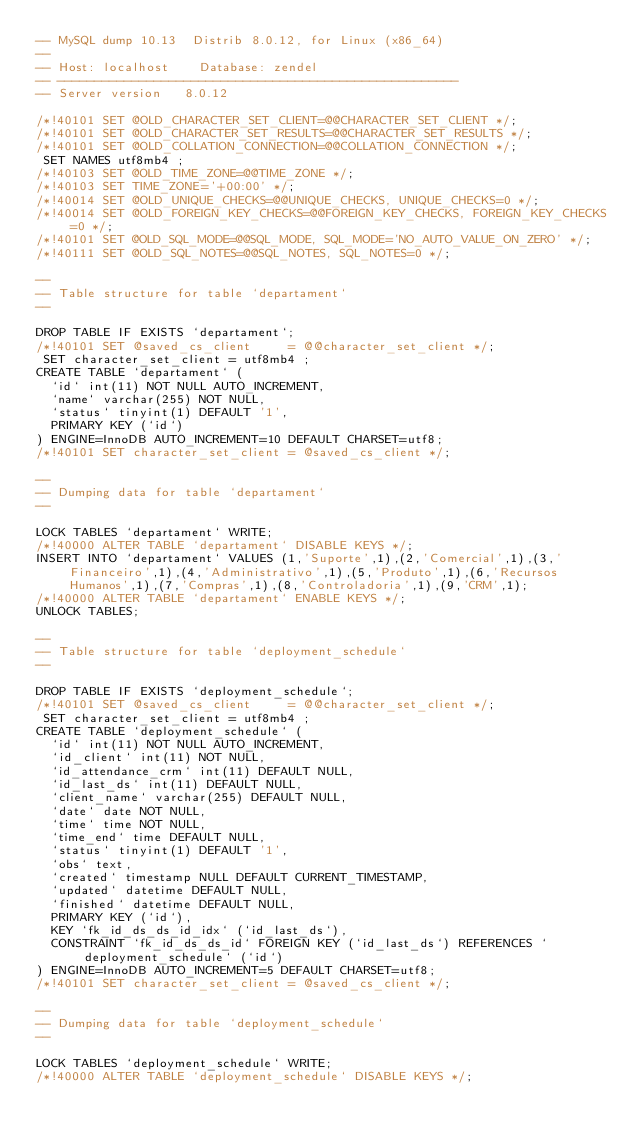<code> <loc_0><loc_0><loc_500><loc_500><_SQL_>-- MySQL dump 10.13  Distrib 8.0.12, for Linux (x86_64)
--
-- Host: localhost    Database: zendel
-- ------------------------------------------------------
-- Server version	8.0.12

/*!40101 SET @OLD_CHARACTER_SET_CLIENT=@@CHARACTER_SET_CLIENT */;
/*!40101 SET @OLD_CHARACTER_SET_RESULTS=@@CHARACTER_SET_RESULTS */;
/*!40101 SET @OLD_COLLATION_CONNECTION=@@COLLATION_CONNECTION */;
 SET NAMES utf8mb4 ;
/*!40103 SET @OLD_TIME_ZONE=@@TIME_ZONE */;
/*!40103 SET TIME_ZONE='+00:00' */;
/*!40014 SET @OLD_UNIQUE_CHECKS=@@UNIQUE_CHECKS, UNIQUE_CHECKS=0 */;
/*!40014 SET @OLD_FOREIGN_KEY_CHECKS=@@FOREIGN_KEY_CHECKS, FOREIGN_KEY_CHECKS=0 */;
/*!40101 SET @OLD_SQL_MODE=@@SQL_MODE, SQL_MODE='NO_AUTO_VALUE_ON_ZERO' */;
/*!40111 SET @OLD_SQL_NOTES=@@SQL_NOTES, SQL_NOTES=0 */;

--
-- Table structure for table `departament`
--

DROP TABLE IF EXISTS `departament`;
/*!40101 SET @saved_cs_client     = @@character_set_client */;
 SET character_set_client = utf8mb4 ;
CREATE TABLE `departament` (
  `id` int(11) NOT NULL AUTO_INCREMENT,
  `name` varchar(255) NOT NULL,
  `status` tinyint(1) DEFAULT '1',
  PRIMARY KEY (`id`)
) ENGINE=InnoDB AUTO_INCREMENT=10 DEFAULT CHARSET=utf8;
/*!40101 SET character_set_client = @saved_cs_client */;

--
-- Dumping data for table `departament`
--

LOCK TABLES `departament` WRITE;
/*!40000 ALTER TABLE `departament` DISABLE KEYS */;
INSERT INTO `departament` VALUES (1,'Suporte',1),(2,'Comercial',1),(3,'Financeiro',1),(4,'Administrativo',1),(5,'Produto',1),(6,'Recursos Humanos',1),(7,'Compras',1),(8,'Controladoria',1),(9,'CRM',1);
/*!40000 ALTER TABLE `departament` ENABLE KEYS */;
UNLOCK TABLES;

--
-- Table structure for table `deployment_schedule`
--

DROP TABLE IF EXISTS `deployment_schedule`;
/*!40101 SET @saved_cs_client     = @@character_set_client */;
 SET character_set_client = utf8mb4 ;
CREATE TABLE `deployment_schedule` (
  `id` int(11) NOT NULL AUTO_INCREMENT,
  `id_client` int(11) NOT NULL,
  `id_attendance_crm` int(11) DEFAULT NULL,
  `id_last_ds` int(11) DEFAULT NULL,
  `client_name` varchar(255) DEFAULT NULL,
  `date` date NOT NULL,
  `time` time NOT NULL,
  `time_end` time DEFAULT NULL,
  `status` tinyint(1) DEFAULT '1',
  `obs` text,
  `created` timestamp NULL DEFAULT CURRENT_TIMESTAMP,
  `updated` datetime DEFAULT NULL,
  `finished` datetime DEFAULT NULL,
  PRIMARY KEY (`id`),
  KEY `fk_id_ds_ds_id_idx` (`id_last_ds`),
  CONSTRAINT `fk_id_ds_ds_id` FOREIGN KEY (`id_last_ds`) REFERENCES `deployment_schedule` (`id`)
) ENGINE=InnoDB AUTO_INCREMENT=5 DEFAULT CHARSET=utf8;
/*!40101 SET character_set_client = @saved_cs_client */;

--
-- Dumping data for table `deployment_schedule`
--

LOCK TABLES `deployment_schedule` WRITE;
/*!40000 ALTER TABLE `deployment_schedule` DISABLE KEYS */;</code> 